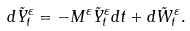<formula> <loc_0><loc_0><loc_500><loc_500>d \tilde { Y } ^ { \varepsilon } _ { t } & = - M ^ { \varepsilon } \tilde { Y } ^ { \varepsilon } _ { t } d t + d \tilde { W } ^ { \varepsilon } _ { t } .</formula> 